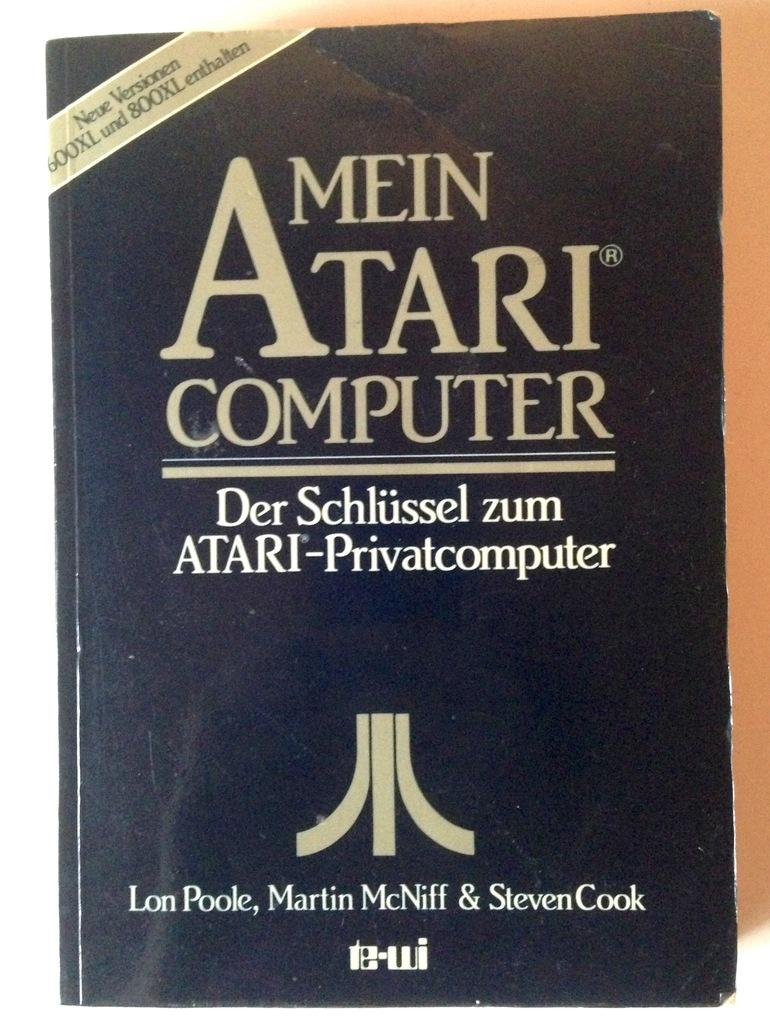<image>
Render a clear and concise summary of the photo. The cover of a German book about Atari computer is shown. 